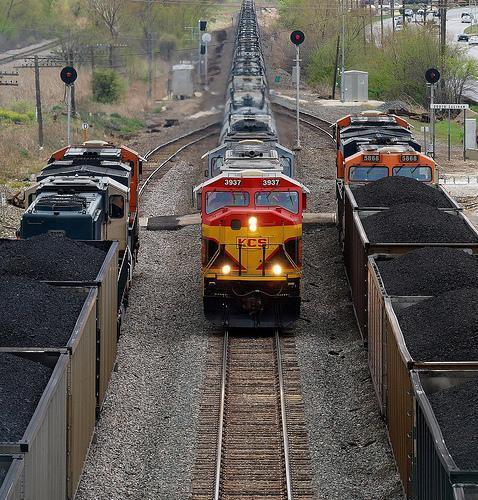How many headlights are lit on the front of the train?
Give a very brief answer. 3. How many of the train cars are yellow and red?
Give a very brief answer. 1. 